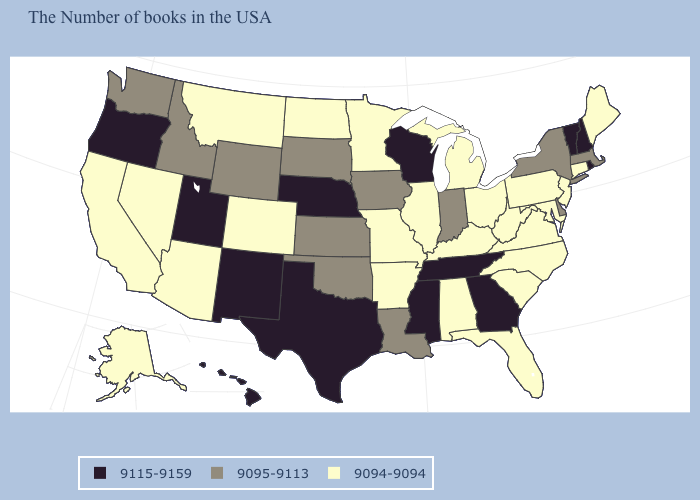Name the states that have a value in the range 9115-9159?
Be succinct. Rhode Island, New Hampshire, Vermont, Georgia, Tennessee, Wisconsin, Mississippi, Nebraska, Texas, New Mexico, Utah, Oregon, Hawaii. Does New Jersey have a lower value than Idaho?
Short answer required. Yes. What is the lowest value in the West?
Answer briefly. 9094-9094. What is the value of California?
Answer briefly. 9094-9094. Name the states that have a value in the range 9094-9094?
Quick response, please. Maine, Connecticut, New Jersey, Maryland, Pennsylvania, Virginia, North Carolina, South Carolina, West Virginia, Ohio, Florida, Michigan, Kentucky, Alabama, Illinois, Missouri, Arkansas, Minnesota, North Dakota, Colorado, Montana, Arizona, Nevada, California, Alaska. Does Ohio have the lowest value in the USA?
Concise answer only. Yes. Name the states that have a value in the range 9095-9113?
Keep it brief. Massachusetts, New York, Delaware, Indiana, Louisiana, Iowa, Kansas, Oklahoma, South Dakota, Wyoming, Idaho, Washington. How many symbols are there in the legend?
Answer briefly. 3. How many symbols are there in the legend?
Short answer required. 3. What is the highest value in the USA?
Keep it brief. 9115-9159. What is the value of Vermont?
Keep it brief. 9115-9159. Name the states that have a value in the range 9094-9094?
Be succinct. Maine, Connecticut, New Jersey, Maryland, Pennsylvania, Virginia, North Carolina, South Carolina, West Virginia, Ohio, Florida, Michigan, Kentucky, Alabama, Illinois, Missouri, Arkansas, Minnesota, North Dakota, Colorado, Montana, Arizona, Nevada, California, Alaska. What is the value of New Jersey?
Keep it brief. 9094-9094. Does Florida have a lower value than Massachusetts?
Short answer required. Yes. What is the lowest value in the Northeast?
Answer briefly. 9094-9094. 